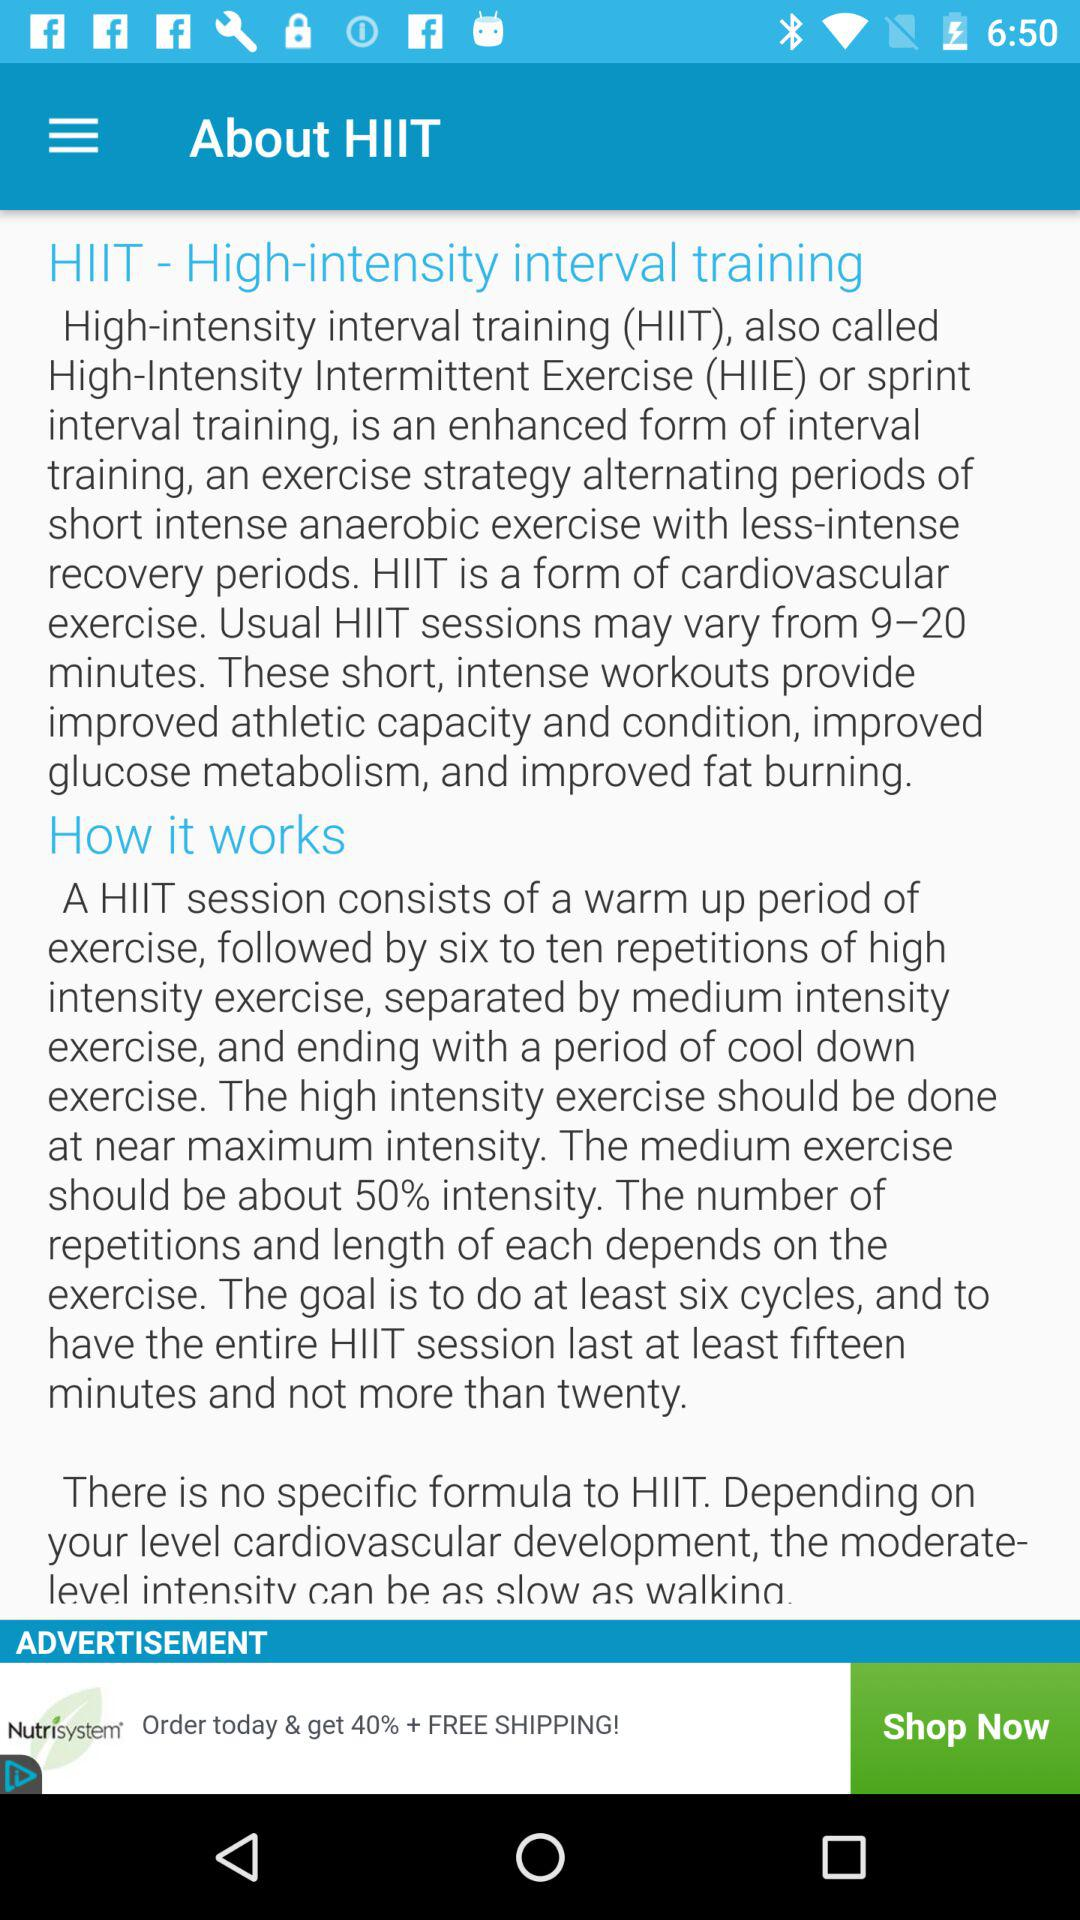What is the goal set for the HIIT session? The goal set for the HIIT session is to do at least six cycles and have the entire HIIT session last at least fifteen minutes and not more than twenty. 